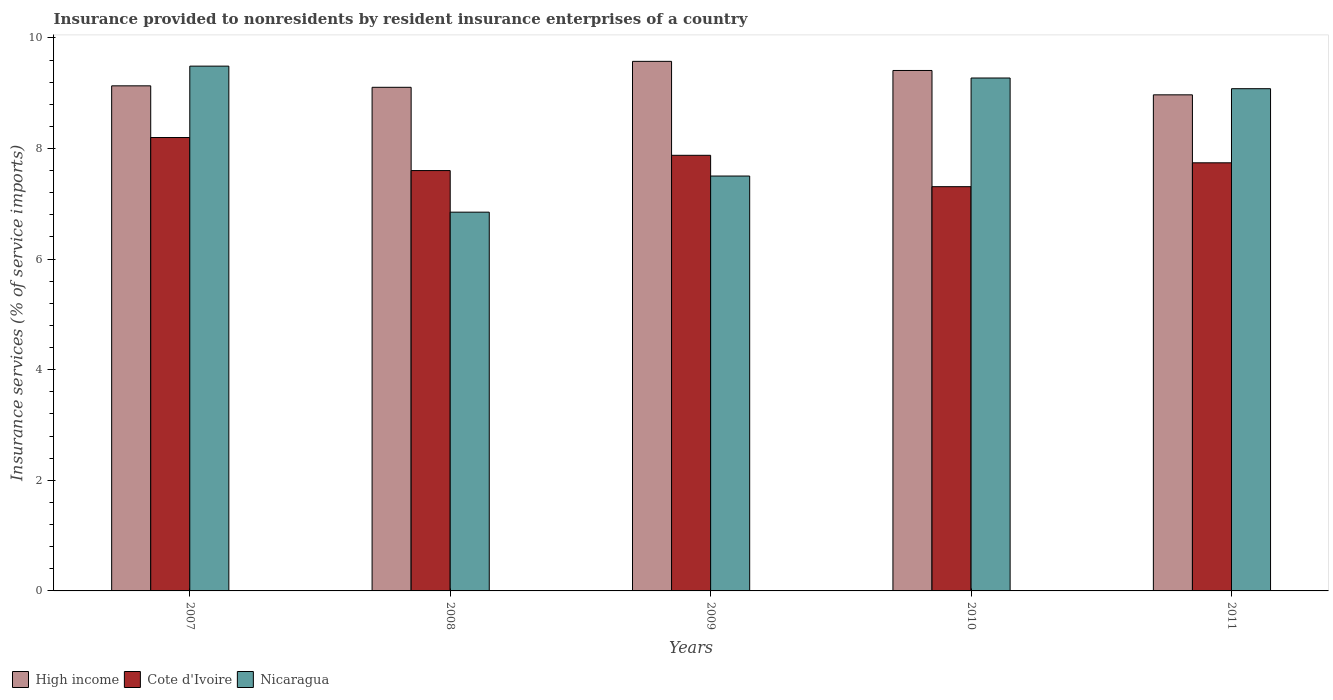Are the number of bars per tick equal to the number of legend labels?
Your response must be concise. Yes. Are the number of bars on each tick of the X-axis equal?
Your answer should be compact. Yes. How many bars are there on the 2nd tick from the right?
Make the answer very short. 3. What is the label of the 1st group of bars from the left?
Make the answer very short. 2007. In how many cases, is the number of bars for a given year not equal to the number of legend labels?
Offer a terse response. 0. What is the insurance provided to nonresidents in Nicaragua in 2009?
Ensure brevity in your answer.  7.5. Across all years, what is the maximum insurance provided to nonresidents in Nicaragua?
Ensure brevity in your answer.  9.49. Across all years, what is the minimum insurance provided to nonresidents in Nicaragua?
Your answer should be compact. 6.85. In which year was the insurance provided to nonresidents in Nicaragua maximum?
Your answer should be very brief. 2007. What is the total insurance provided to nonresidents in High income in the graph?
Your response must be concise. 46.2. What is the difference between the insurance provided to nonresidents in Nicaragua in 2008 and that in 2011?
Give a very brief answer. -2.23. What is the difference between the insurance provided to nonresidents in Nicaragua in 2007 and the insurance provided to nonresidents in Cote d'Ivoire in 2009?
Your answer should be very brief. 1.61. What is the average insurance provided to nonresidents in Cote d'Ivoire per year?
Your answer should be very brief. 7.75. In the year 2009, what is the difference between the insurance provided to nonresidents in High income and insurance provided to nonresidents in Nicaragua?
Provide a succinct answer. 2.07. What is the ratio of the insurance provided to nonresidents in Cote d'Ivoire in 2007 to that in 2011?
Offer a terse response. 1.06. Is the insurance provided to nonresidents in Cote d'Ivoire in 2010 less than that in 2011?
Your answer should be very brief. Yes. Is the difference between the insurance provided to nonresidents in High income in 2009 and 2010 greater than the difference between the insurance provided to nonresidents in Nicaragua in 2009 and 2010?
Your answer should be very brief. Yes. What is the difference between the highest and the second highest insurance provided to nonresidents in Cote d'Ivoire?
Provide a succinct answer. 0.32. What is the difference between the highest and the lowest insurance provided to nonresidents in Nicaragua?
Provide a succinct answer. 2.64. Is the sum of the insurance provided to nonresidents in High income in 2007 and 2010 greater than the maximum insurance provided to nonresidents in Nicaragua across all years?
Provide a short and direct response. Yes. What does the 2nd bar from the left in 2010 represents?
Your answer should be compact. Cote d'Ivoire. What does the 1st bar from the right in 2010 represents?
Ensure brevity in your answer.  Nicaragua. Is it the case that in every year, the sum of the insurance provided to nonresidents in Nicaragua and insurance provided to nonresidents in Cote d'Ivoire is greater than the insurance provided to nonresidents in High income?
Keep it short and to the point. Yes. How many years are there in the graph?
Your response must be concise. 5. What is the difference between two consecutive major ticks on the Y-axis?
Offer a very short reply. 2. Are the values on the major ticks of Y-axis written in scientific E-notation?
Make the answer very short. No. Does the graph contain any zero values?
Provide a short and direct response. No. Does the graph contain grids?
Your answer should be very brief. No. How many legend labels are there?
Offer a very short reply. 3. How are the legend labels stacked?
Provide a short and direct response. Horizontal. What is the title of the graph?
Keep it short and to the point. Insurance provided to nonresidents by resident insurance enterprises of a country. Does "Honduras" appear as one of the legend labels in the graph?
Your answer should be very brief. No. What is the label or title of the X-axis?
Your answer should be very brief. Years. What is the label or title of the Y-axis?
Make the answer very short. Insurance services (% of service imports). What is the Insurance services (% of service imports) of High income in 2007?
Your response must be concise. 9.13. What is the Insurance services (% of service imports) of Cote d'Ivoire in 2007?
Provide a succinct answer. 8.2. What is the Insurance services (% of service imports) of Nicaragua in 2007?
Your response must be concise. 9.49. What is the Insurance services (% of service imports) in High income in 2008?
Provide a short and direct response. 9.11. What is the Insurance services (% of service imports) in Cote d'Ivoire in 2008?
Your response must be concise. 7.6. What is the Insurance services (% of service imports) of Nicaragua in 2008?
Offer a terse response. 6.85. What is the Insurance services (% of service imports) in High income in 2009?
Make the answer very short. 9.58. What is the Insurance services (% of service imports) of Cote d'Ivoire in 2009?
Provide a short and direct response. 7.88. What is the Insurance services (% of service imports) in Nicaragua in 2009?
Your answer should be compact. 7.5. What is the Insurance services (% of service imports) in High income in 2010?
Offer a very short reply. 9.41. What is the Insurance services (% of service imports) of Cote d'Ivoire in 2010?
Ensure brevity in your answer.  7.31. What is the Insurance services (% of service imports) of Nicaragua in 2010?
Your answer should be compact. 9.27. What is the Insurance services (% of service imports) in High income in 2011?
Your answer should be compact. 8.97. What is the Insurance services (% of service imports) of Cote d'Ivoire in 2011?
Provide a succinct answer. 7.74. What is the Insurance services (% of service imports) in Nicaragua in 2011?
Provide a succinct answer. 9.08. Across all years, what is the maximum Insurance services (% of service imports) of High income?
Make the answer very short. 9.58. Across all years, what is the maximum Insurance services (% of service imports) in Cote d'Ivoire?
Offer a very short reply. 8.2. Across all years, what is the maximum Insurance services (% of service imports) of Nicaragua?
Offer a very short reply. 9.49. Across all years, what is the minimum Insurance services (% of service imports) of High income?
Keep it short and to the point. 8.97. Across all years, what is the minimum Insurance services (% of service imports) in Cote d'Ivoire?
Provide a succinct answer. 7.31. Across all years, what is the minimum Insurance services (% of service imports) of Nicaragua?
Offer a terse response. 6.85. What is the total Insurance services (% of service imports) in High income in the graph?
Your answer should be very brief. 46.2. What is the total Insurance services (% of service imports) of Cote d'Ivoire in the graph?
Offer a very short reply. 38.73. What is the total Insurance services (% of service imports) in Nicaragua in the graph?
Offer a terse response. 42.2. What is the difference between the Insurance services (% of service imports) in High income in 2007 and that in 2008?
Your answer should be compact. 0.03. What is the difference between the Insurance services (% of service imports) of Cote d'Ivoire in 2007 and that in 2008?
Provide a short and direct response. 0.6. What is the difference between the Insurance services (% of service imports) of Nicaragua in 2007 and that in 2008?
Make the answer very short. 2.64. What is the difference between the Insurance services (% of service imports) of High income in 2007 and that in 2009?
Ensure brevity in your answer.  -0.44. What is the difference between the Insurance services (% of service imports) in Cote d'Ivoire in 2007 and that in 2009?
Your answer should be compact. 0.32. What is the difference between the Insurance services (% of service imports) of Nicaragua in 2007 and that in 2009?
Make the answer very short. 1.99. What is the difference between the Insurance services (% of service imports) in High income in 2007 and that in 2010?
Ensure brevity in your answer.  -0.28. What is the difference between the Insurance services (% of service imports) in Cote d'Ivoire in 2007 and that in 2010?
Your response must be concise. 0.89. What is the difference between the Insurance services (% of service imports) of Nicaragua in 2007 and that in 2010?
Provide a succinct answer. 0.21. What is the difference between the Insurance services (% of service imports) of High income in 2007 and that in 2011?
Keep it short and to the point. 0.16. What is the difference between the Insurance services (% of service imports) in Cote d'Ivoire in 2007 and that in 2011?
Your response must be concise. 0.46. What is the difference between the Insurance services (% of service imports) of Nicaragua in 2007 and that in 2011?
Your response must be concise. 0.41. What is the difference between the Insurance services (% of service imports) of High income in 2008 and that in 2009?
Your response must be concise. -0.47. What is the difference between the Insurance services (% of service imports) of Cote d'Ivoire in 2008 and that in 2009?
Your response must be concise. -0.28. What is the difference between the Insurance services (% of service imports) of Nicaragua in 2008 and that in 2009?
Your answer should be compact. -0.65. What is the difference between the Insurance services (% of service imports) in High income in 2008 and that in 2010?
Your response must be concise. -0.3. What is the difference between the Insurance services (% of service imports) of Cote d'Ivoire in 2008 and that in 2010?
Offer a very short reply. 0.29. What is the difference between the Insurance services (% of service imports) of Nicaragua in 2008 and that in 2010?
Provide a short and direct response. -2.43. What is the difference between the Insurance services (% of service imports) of High income in 2008 and that in 2011?
Keep it short and to the point. 0.14. What is the difference between the Insurance services (% of service imports) of Cote d'Ivoire in 2008 and that in 2011?
Offer a very short reply. -0.14. What is the difference between the Insurance services (% of service imports) in Nicaragua in 2008 and that in 2011?
Offer a terse response. -2.23. What is the difference between the Insurance services (% of service imports) in High income in 2009 and that in 2010?
Keep it short and to the point. 0.17. What is the difference between the Insurance services (% of service imports) in Cote d'Ivoire in 2009 and that in 2010?
Provide a succinct answer. 0.57. What is the difference between the Insurance services (% of service imports) in Nicaragua in 2009 and that in 2010?
Your answer should be compact. -1.77. What is the difference between the Insurance services (% of service imports) of High income in 2009 and that in 2011?
Offer a very short reply. 0.61. What is the difference between the Insurance services (% of service imports) in Cote d'Ivoire in 2009 and that in 2011?
Provide a short and direct response. 0.14. What is the difference between the Insurance services (% of service imports) in Nicaragua in 2009 and that in 2011?
Offer a very short reply. -1.58. What is the difference between the Insurance services (% of service imports) of High income in 2010 and that in 2011?
Your answer should be compact. 0.44. What is the difference between the Insurance services (% of service imports) in Cote d'Ivoire in 2010 and that in 2011?
Provide a short and direct response. -0.43. What is the difference between the Insurance services (% of service imports) of Nicaragua in 2010 and that in 2011?
Make the answer very short. 0.19. What is the difference between the Insurance services (% of service imports) of High income in 2007 and the Insurance services (% of service imports) of Cote d'Ivoire in 2008?
Provide a short and direct response. 1.53. What is the difference between the Insurance services (% of service imports) of High income in 2007 and the Insurance services (% of service imports) of Nicaragua in 2008?
Keep it short and to the point. 2.28. What is the difference between the Insurance services (% of service imports) in Cote d'Ivoire in 2007 and the Insurance services (% of service imports) in Nicaragua in 2008?
Provide a short and direct response. 1.35. What is the difference between the Insurance services (% of service imports) of High income in 2007 and the Insurance services (% of service imports) of Cote d'Ivoire in 2009?
Give a very brief answer. 1.26. What is the difference between the Insurance services (% of service imports) of High income in 2007 and the Insurance services (% of service imports) of Nicaragua in 2009?
Provide a short and direct response. 1.63. What is the difference between the Insurance services (% of service imports) of Cote d'Ivoire in 2007 and the Insurance services (% of service imports) of Nicaragua in 2009?
Your response must be concise. 0.7. What is the difference between the Insurance services (% of service imports) in High income in 2007 and the Insurance services (% of service imports) in Cote d'Ivoire in 2010?
Your answer should be very brief. 1.82. What is the difference between the Insurance services (% of service imports) of High income in 2007 and the Insurance services (% of service imports) of Nicaragua in 2010?
Make the answer very short. -0.14. What is the difference between the Insurance services (% of service imports) of Cote d'Ivoire in 2007 and the Insurance services (% of service imports) of Nicaragua in 2010?
Make the answer very short. -1.08. What is the difference between the Insurance services (% of service imports) in High income in 2007 and the Insurance services (% of service imports) in Cote d'Ivoire in 2011?
Give a very brief answer. 1.39. What is the difference between the Insurance services (% of service imports) of High income in 2007 and the Insurance services (% of service imports) of Nicaragua in 2011?
Provide a short and direct response. 0.05. What is the difference between the Insurance services (% of service imports) in Cote d'Ivoire in 2007 and the Insurance services (% of service imports) in Nicaragua in 2011?
Provide a short and direct response. -0.88. What is the difference between the Insurance services (% of service imports) in High income in 2008 and the Insurance services (% of service imports) in Cote d'Ivoire in 2009?
Your answer should be very brief. 1.23. What is the difference between the Insurance services (% of service imports) in High income in 2008 and the Insurance services (% of service imports) in Nicaragua in 2009?
Provide a short and direct response. 1.6. What is the difference between the Insurance services (% of service imports) in Cote d'Ivoire in 2008 and the Insurance services (% of service imports) in Nicaragua in 2009?
Provide a succinct answer. 0.1. What is the difference between the Insurance services (% of service imports) of High income in 2008 and the Insurance services (% of service imports) of Cote d'Ivoire in 2010?
Ensure brevity in your answer.  1.8. What is the difference between the Insurance services (% of service imports) of High income in 2008 and the Insurance services (% of service imports) of Nicaragua in 2010?
Provide a short and direct response. -0.17. What is the difference between the Insurance services (% of service imports) of Cote d'Ivoire in 2008 and the Insurance services (% of service imports) of Nicaragua in 2010?
Offer a very short reply. -1.67. What is the difference between the Insurance services (% of service imports) of High income in 2008 and the Insurance services (% of service imports) of Cote d'Ivoire in 2011?
Offer a terse response. 1.37. What is the difference between the Insurance services (% of service imports) in High income in 2008 and the Insurance services (% of service imports) in Nicaragua in 2011?
Provide a short and direct response. 0.03. What is the difference between the Insurance services (% of service imports) in Cote d'Ivoire in 2008 and the Insurance services (% of service imports) in Nicaragua in 2011?
Your response must be concise. -1.48. What is the difference between the Insurance services (% of service imports) in High income in 2009 and the Insurance services (% of service imports) in Cote d'Ivoire in 2010?
Your answer should be compact. 2.27. What is the difference between the Insurance services (% of service imports) of High income in 2009 and the Insurance services (% of service imports) of Nicaragua in 2010?
Provide a short and direct response. 0.3. What is the difference between the Insurance services (% of service imports) in Cote d'Ivoire in 2009 and the Insurance services (% of service imports) in Nicaragua in 2010?
Your answer should be very brief. -1.4. What is the difference between the Insurance services (% of service imports) in High income in 2009 and the Insurance services (% of service imports) in Cote d'Ivoire in 2011?
Your answer should be compact. 1.83. What is the difference between the Insurance services (% of service imports) of High income in 2009 and the Insurance services (% of service imports) of Nicaragua in 2011?
Provide a succinct answer. 0.49. What is the difference between the Insurance services (% of service imports) of Cote d'Ivoire in 2009 and the Insurance services (% of service imports) of Nicaragua in 2011?
Offer a very short reply. -1.2. What is the difference between the Insurance services (% of service imports) of High income in 2010 and the Insurance services (% of service imports) of Cote d'Ivoire in 2011?
Give a very brief answer. 1.67. What is the difference between the Insurance services (% of service imports) in High income in 2010 and the Insurance services (% of service imports) in Nicaragua in 2011?
Your answer should be compact. 0.33. What is the difference between the Insurance services (% of service imports) in Cote d'Ivoire in 2010 and the Insurance services (% of service imports) in Nicaragua in 2011?
Give a very brief answer. -1.77. What is the average Insurance services (% of service imports) of High income per year?
Your answer should be very brief. 9.24. What is the average Insurance services (% of service imports) in Cote d'Ivoire per year?
Ensure brevity in your answer.  7.75. What is the average Insurance services (% of service imports) in Nicaragua per year?
Provide a short and direct response. 8.44. In the year 2007, what is the difference between the Insurance services (% of service imports) in High income and Insurance services (% of service imports) in Cote d'Ivoire?
Offer a terse response. 0.93. In the year 2007, what is the difference between the Insurance services (% of service imports) in High income and Insurance services (% of service imports) in Nicaragua?
Provide a succinct answer. -0.36. In the year 2007, what is the difference between the Insurance services (% of service imports) of Cote d'Ivoire and Insurance services (% of service imports) of Nicaragua?
Your answer should be compact. -1.29. In the year 2008, what is the difference between the Insurance services (% of service imports) in High income and Insurance services (% of service imports) in Cote d'Ivoire?
Your response must be concise. 1.51. In the year 2008, what is the difference between the Insurance services (% of service imports) of High income and Insurance services (% of service imports) of Nicaragua?
Ensure brevity in your answer.  2.26. In the year 2008, what is the difference between the Insurance services (% of service imports) in Cote d'Ivoire and Insurance services (% of service imports) in Nicaragua?
Your answer should be very brief. 0.75. In the year 2009, what is the difference between the Insurance services (% of service imports) of High income and Insurance services (% of service imports) of Cote d'Ivoire?
Provide a short and direct response. 1.7. In the year 2009, what is the difference between the Insurance services (% of service imports) of High income and Insurance services (% of service imports) of Nicaragua?
Your answer should be compact. 2.07. In the year 2009, what is the difference between the Insurance services (% of service imports) of Cote d'Ivoire and Insurance services (% of service imports) of Nicaragua?
Provide a short and direct response. 0.37. In the year 2010, what is the difference between the Insurance services (% of service imports) in High income and Insurance services (% of service imports) in Cote d'Ivoire?
Your answer should be compact. 2.1. In the year 2010, what is the difference between the Insurance services (% of service imports) of High income and Insurance services (% of service imports) of Nicaragua?
Provide a short and direct response. 0.14. In the year 2010, what is the difference between the Insurance services (% of service imports) in Cote d'Ivoire and Insurance services (% of service imports) in Nicaragua?
Keep it short and to the point. -1.97. In the year 2011, what is the difference between the Insurance services (% of service imports) in High income and Insurance services (% of service imports) in Cote d'Ivoire?
Provide a short and direct response. 1.23. In the year 2011, what is the difference between the Insurance services (% of service imports) in High income and Insurance services (% of service imports) in Nicaragua?
Give a very brief answer. -0.11. In the year 2011, what is the difference between the Insurance services (% of service imports) in Cote d'Ivoire and Insurance services (% of service imports) in Nicaragua?
Provide a short and direct response. -1.34. What is the ratio of the Insurance services (% of service imports) of Cote d'Ivoire in 2007 to that in 2008?
Your answer should be compact. 1.08. What is the ratio of the Insurance services (% of service imports) of Nicaragua in 2007 to that in 2008?
Your response must be concise. 1.39. What is the ratio of the Insurance services (% of service imports) in High income in 2007 to that in 2009?
Your answer should be very brief. 0.95. What is the ratio of the Insurance services (% of service imports) in Cote d'Ivoire in 2007 to that in 2009?
Provide a short and direct response. 1.04. What is the ratio of the Insurance services (% of service imports) of Nicaragua in 2007 to that in 2009?
Offer a very short reply. 1.26. What is the ratio of the Insurance services (% of service imports) of High income in 2007 to that in 2010?
Your response must be concise. 0.97. What is the ratio of the Insurance services (% of service imports) in Cote d'Ivoire in 2007 to that in 2010?
Offer a terse response. 1.12. What is the ratio of the Insurance services (% of service imports) of Nicaragua in 2007 to that in 2010?
Provide a short and direct response. 1.02. What is the ratio of the Insurance services (% of service imports) of High income in 2007 to that in 2011?
Provide a short and direct response. 1.02. What is the ratio of the Insurance services (% of service imports) of Cote d'Ivoire in 2007 to that in 2011?
Your answer should be compact. 1.06. What is the ratio of the Insurance services (% of service imports) of Nicaragua in 2007 to that in 2011?
Keep it short and to the point. 1.04. What is the ratio of the Insurance services (% of service imports) of High income in 2008 to that in 2009?
Offer a very short reply. 0.95. What is the ratio of the Insurance services (% of service imports) of Cote d'Ivoire in 2008 to that in 2009?
Keep it short and to the point. 0.96. What is the ratio of the Insurance services (% of service imports) of Nicaragua in 2008 to that in 2009?
Offer a very short reply. 0.91. What is the ratio of the Insurance services (% of service imports) of Cote d'Ivoire in 2008 to that in 2010?
Your answer should be very brief. 1.04. What is the ratio of the Insurance services (% of service imports) in Nicaragua in 2008 to that in 2010?
Offer a very short reply. 0.74. What is the ratio of the Insurance services (% of service imports) of High income in 2008 to that in 2011?
Ensure brevity in your answer.  1.02. What is the ratio of the Insurance services (% of service imports) in Cote d'Ivoire in 2008 to that in 2011?
Make the answer very short. 0.98. What is the ratio of the Insurance services (% of service imports) in Nicaragua in 2008 to that in 2011?
Offer a very short reply. 0.75. What is the ratio of the Insurance services (% of service imports) of High income in 2009 to that in 2010?
Your answer should be very brief. 1.02. What is the ratio of the Insurance services (% of service imports) in Cote d'Ivoire in 2009 to that in 2010?
Give a very brief answer. 1.08. What is the ratio of the Insurance services (% of service imports) in Nicaragua in 2009 to that in 2010?
Provide a short and direct response. 0.81. What is the ratio of the Insurance services (% of service imports) of High income in 2009 to that in 2011?
Your answer should be very brief. 1.07. What is the ratio of the Insurance services (% of service imports) of Cote d'Ivoire in 2009 to that in 2011?
Offer a very short reply. 1.02. What is the ratio of the Insurance services (% of service imports) of Nicaragua in 2009 to that in 2011?
Provide a succinct answer. 0.83. What is the ratio of the Insurance services (% of service imports) in High income in 2010 to that in 2011?
Offer a terse response. 1.05. What is the ratio of the Insurance services (% of service imports) of Cote d'Ivoire in 2010 to that in 2011?
Your response must be concise. 0.94. What is the ratio of the Insurance services (% of service imports) of Nicaragua in 2010 to that in 2011?
Offer a very short reply. 1.02. What is the difference between the highest and the second highest Insurance services (% of service imports) in High income?
Provide a succinct answer. 0.17. What is the difference between the highest and the second highest Insurance services (% of service imports) of Cote d'Ivoire?
Make the answer very short. 0.32. What is the difference between the highest and the second highest Insurance services (% of service imports) of Nicaragua?
Your response must be concise. 0.21. What is the difference between the highest and the lowest Insurance services (% of service imports) of High income?
Keep it short and to the point. 0.61. What is the difference between the highest and the lowest Insurance services (% of service imports) of Cote d'Ivoire?
Your answer should be compact. 0.89. What is the difference between the highest and the lowest Insurance services (% of service imports) in Nicaragua?
Offer a terse response. 2.64. 